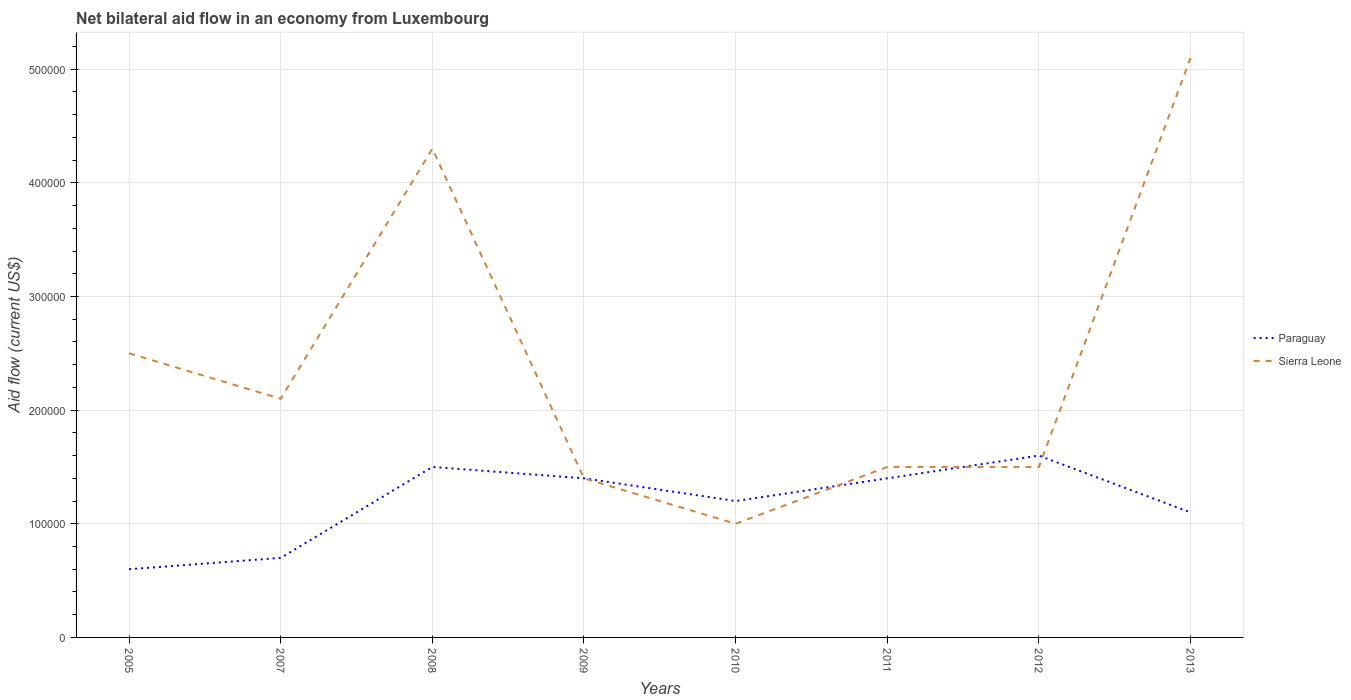How many different coloured lines are there?
Provide a short and direct response. 2. Does the line corresponding to Sierra Leone intersect with the line corresponding to Paraguay?
Keep it short and to the point. Yes. Across all years, what is the maximum net bilateral aid flow in Paraguay?
Provide a succinct answer. 6.00e+04. In which year was the net bilateral aid flow in Sierra Leone maximum?
Keep it short and to the point. 2010. What is the total net bilateral aid flow in Sierra Leone in the graph?
Your answer should be very brief. 1.10e+05. What is the difference between the highest and the second highest net bilateral aid flow in Paraguay?
Make the answer very short. 1.00e+05. Is the net bilateral aid flow in Paraguay strictly greater than the net bilateral aid flow in Sierra Leone over the years?
Offer a very short reply. No. How many lines are there?
Provide a short and direct response. 2. How many years are there in the graph?
Your answer should be compact. 8. Are the values on the major ticks of Y-axis written in scientific E-notation?
Provide a succinct answer. No. Does the graph contain grids?
Provide a succinct answer. Yes. What is the title of the graph?
Offer a very short reply. Net bilateral aid flow in an economy from Luxembourg. Does "Fiji" appear as one of the legend labels in the graph?
Ensure brevity in your answer.  No. What is the label or title of the X-axis?
Offer a terse response. Years. What is the label or title of the Y-axis?
Your answer should be very brief. Aid flow (current US$). What is the Aid flow (current US$) in Paraguay in 2005?
Make the answer very short. 6.00e+04. What is the Aid flow (current US$) of Sierra Leone in 2005?
Make the answer very short. 2.50e+05. What is the Aid flow (current US$) of Paraguay in 2007?
Provide a short and direct response. 7.00e+04. What is the Aid flow (current US$) of Sierra Leone in 2008?
Your answer should be compact. 4.30e+05. What is the Aid flow (current US$) in Paraguay in 2009?
Offer a very short reply. 1.40e+05. What is the Aid flow (current US$) of Paraguay in 2010?
Your answer should be very brief. 1.20e+05. What is the Aid flow (current US$) of Paraguay in 2011?
Your answer should be compact. 1.40e+05. What is the Aid flow (current US$) of Sierra Leone in 2011?
Make the answer very short. 1.50e+05. What is the Aid flow (current US$) in Paraguay in 2012?
Make the answer very short. 1.60e+05. What is the Aid flow (current US$) of Sierra Leone in 2012?
Your response must be concise. 1.50e+05. What is the Aid flow (current US$) of Paraguay in 2013?
Your response must be concise. 1.10e+05. What is the Aid flow (current US$) of Sierra Leone in 2013?
Give a very brief answer. 5.10e+05. Across all years, what is the maximum Aid flow (current US$) of Sierra Leone?
Provide a succinct answer. 5.10e+05. What is the total Aid flow (current US$) of Paraguay in the graph?
Provide a succinct answer. 9.50e+05. What is the total Aid flow (current US$) of Sierra Leone in the graph?
Make the answer very short. 1.94e+06. What is the difference between the Aid flow (current US$) in Sierra Leone in 2005 and that in 2007?
Offer a terse response. 4.00e+04. What is the difference between the Aid flow (current US$) of Paraguay in 2005 and that in 2008?
Offer a terse response. -9.00e+04. What is the difference between the Aid flow (current US$) in Paraguay in 2005 and that in 2009?
Your answer should be very brief. -8.00e+04. What is the difference between the Aid flow (current US$) of Paraguay in 2005 and that in 2010?
Offer a terse response. -6.00e+04. What is the difference between the Aid flow (current US$) of Paraguay in 2005 and that in 2011?
Your answer should be compact. -8.00e+04. What is the difference between the Aid flow (current US$) of Sierra Leone in 2005 and that in 2011?
Your answer should be very brief. 1.00e+05. What is the difference between the Aid flow (current US$) in Paraguay in 2005 and that in 2012?
Your response must be concise. -1.00e+05. What is the difference between the Aid flow (current US$) in Sierra Leone in 2005 and that in 2012?
Your answer should be very brief. 1.00e+05. What is the difference between the Aid flow (current US$) in Sierra Leone in 2005 and that in 2013?
Your response must be concise. -2.60e+05. What is the difference between the Aid flow (current US$) in Paraguay in 2007 and that in 2009?
Offer a very short reply. -7.00e+04. What is the difference between the Aid flow (current US$) of Paraguay in 2007 and that in 2010?
Ensure brevity in your answer.  -5.00e+04. What is the difference between the Aid flow (current US$) of Paraguay in 2007 and that in 2011?
Offer a terse response. -7.00e+04. What is the difference between the Aid flow (current US$) of Paraguay in 2007 and that in 2012?
Keep it short and to the point. -9.00e+04. What is the difference between the Aid flow (current US$) of Sierra Leone in 2007 and that in 2012?
Your response must be concise. 6.00e+04. What is the difference between the Aid flow (current US$) in Paraguay in 2007 and that in 2013?
Make the answer very short. -4.00e+04. What is the difference between the Aid flow (current US$) of Sierra Leone in 2007 and that in 2013?
Ensure brevity in your answer.  -3.00e+05. What is the difference between the Aid flow (current US$) of Paraguay in 2008 and that in 2009?
Your answer should be very brief. 10000. What is the difference between the Aid flow (current US$) in Paraguay in 2008 and that in 2010?
Make the answer very short. 3.00e+04. What is the difference between the Aid flow (current US$) in Sierra Leone in 2008 and that in 2010?
Keep it short and to the point. 3.30e+05. What is the difference between the Aid flow (current US$) of Sierra Leone in 2008 and that in 2011?
Ensure brevity in your answer.  2.80e+05. What is the difference between the Aid flow (current US$) in Paraguay in 2009 and that in 2010?
Provide a short and direct response. 2.00e+04. What is the difference between the Aid flow (current US$) of Sierra Leone in 2009 and that in 2013?
Give a very brief answer. -3.70e+05. What is the difference between the Aid flow (current US$) in Paraguay in 2010 and that in 2011?
Provide a succinct answer. -2.00e+04. What is the difference between the Aid flow (current US$) in Sierra Leone in 2010 and that in 2011?
Make the answer very short. -5.00e+04. What is the difference between the Aid flow (current US$) in Sierra Leone in 2010 and that in 2013?
Make the answer very short. -4.10e+05. What is the difference between the Aid flow (current US$) of Paraguay in 2011 and that in 2012?
Provide a short and direct response. -2.00e+04. What is the difference between the Aid flow (current US$) of Sierra Leone in 2011 and that in 2013?
Your answer should be very brief. -3.60e+05. What is the difference between the Aid flow (current US$) of Paraguay in 2012 and that in 2013?
Your response must be concise. 5.00e+04. What is the difference between the Aid flow (current US$) in Sierra Leone in 2012 and that in 2013?
Your answer should be compact. -3.60e+05. What is the difference between the Aid flow (current US$) of Paraguay in 2005 and the Aid flow (current US$) of Sierra Leone in 2008?
Provide a succinct answer. -3.70e+05. What is the difference between the Aid flow (current US$) in Paraguay in 2005 and the Aid flow (current US$) in Sierra Leone in 2009?
Make the answer very short. -8.00e+04. What is the difference between the Aid flow (current US$) of Paraguay in 2005 and the Aid flow (current US$) of Sierra Leone in 2010?
Make the answer very short. -4.00e+04. What is the difference between the Aid flow (current US$) of Paraguay in 2005 and the Aid flow (current US$) of Sierra Leone in 2012?
Your answer should be compact. -9.00e+04. What is the difference between the Aid flow (current US$) in Paraguay in 2005 and the Aid flow (current US$) in Sierra Leone in 2013?
Provide a short and direct response. -4.50e+05. What is the difference between the Aid flow (current US$) of Paraguay in 2007 and the Aid flow (current US$) of Sierra Leone in 2008?
Ensure brevity in your answer.  -3.60e+05. What is the difference between the Aid flow (current US$) of Paraguay in 2007 and the Aid flow (current US$) of Sierra Leone in 2011?
Your answer should be very brief. -8.00e+04. What is the difference between the Aid flow (current US$) in Paraguay in 2007 and the Aid flow (current US$) in Sierra Leone in 2012?
Give a very brief answer. -8.00e+04. What is the difference between the Aid flow (current US$) of Paraguay in 2007 and the Aid flow (current US$) of Sierra Leone in 2013?
Provide a short and direct response. -4.40e+05. What is the difference between the Aid flow (current US$) in Paraguay in 2008 and the Aid flow (current US$) in Sierra Leone in 2012?
Provide a short and direct response. 0. What is the difference between the Aid flow (current US$) in Paraguay in 2008 and the Aid flow (current US$) in Sierra Leone in 2013?
Keep it short and to the point. -3.60e+05. What is the difference between the Aid flow (current US$) of Paraguay in 2009 and the Aid flow (current US$) of Sierra Leone in 2012?
Offer a terse response. -10000. What is the difference between the Aid flow (current US$) in Paraguay in 2009 and the Aid flow (current US$) in Sierra Leone in 2013?
Provide a succinct answer. -3.70e+05. What is the difference between the Aid flow (current US$) in Paraguay in 2010 and the Aid flow (current US$) in Sierra Leone in 2013?
Your answer should be very brief. -3.90e+05. What is the difference between the Aid flow (current US$) of Paraguay in 2011 and the Aid flow (current US$) of Sierra Leone in 2013?
Offer a terse response. -3.70e+05. What is the difference between the Aid flow (current US$) in Paraguay in 2012 and the Aid flow (current US$) in Sierra Leone in 2013?
Give a very brief answer. -3.50e+05. What is the average Aid flow (current US$) of Paraguay per year?
Offer a very short reply. 1.19e+05. What is the average Aid flow (current US$) of Sierra Leone per year?
Your answer should be very brief. 2.42e+05. In the year 2005, what is the difference between the Aid flow (current US$) in Paraguay and Aid flow (current US$) in Sierra Leone?
Offer a terse response. -1.90e+05. In the year 2007, what is the difference between the Aid flow (current US$) of Paraguay and Aid flow (current US$) of Sierra Leone?
Ensure brevity in your answer.  -1.40e+05. In the year 2008, what is the difference between the Aid flow (current US$) of Paraguay and Aid flow (current US$) of Sierra Leone?
Offer a terse response. -2.80e+05. In the year 2009, what is the difference between the Aid flow (current US$) in Paraguay and Aid flow (current US$) in Sierra Leone?
Offer a terse response. 0. In the year 2011, what is the difference between the Aid flow (current US$) in Paraguay and Aid flow (current US$) in Sierra Leone?
Your answer should be very brief. -10000. In the year 2013, what is the difference between the Aid flow (current US$) in Paraguay and Aid flow (current US$) in Sierra Leone?
Provide a short and direct response. -4.00e+05. What is the ratio of the Aid flow (current US$) of Sierra Leone in 2005 to that in 2007?
Offer a terse response. 1.19. What is the ratio of the Aid flow (current US$) in Paraguay in 2005 to that in 2008?
Offer a very short reply. 0.4. What is the ratio of the Aid flow (current US$) in Sierra Leone in 2005 to that in 2008?
Make the answer very short. 0.58. What is the ratio of the Aid flow (current US$) of Paraguay in 2005 to that in 2009?
Your answer should be compact. 0.43. What is the ratio of the Aid flow (current US$) in Sierra Leone in 2005 to that in 2009?
Give a very brief answer. 1.79. What is the ratio of the Aid flow (current US$) of Paraguay in 2005 to that in 2011?
Your response must be concise. 0.43. What is the ratio of the Aid flow (current US$) in Sierra Leone in 2005 to that in 2011?
Offer a terse response. 1.67. What is the ratio of the Aid flow (current US$) in Sierra Leone in 2005 to that in 2012?
Make the answer very short. 1.67. What is the ratio of the Aid flow (current US$) in Paraguay in 2005 to that in 2013?
Your answer should be compact. 0.55. What is the ratio of the Aid flow (current US$) of Sierra Leone in 2005 to that in 2013?
Provide a succinct answer. 0.49. What is the ratio of the Aid flow (current US$) of Paraguay in 2007 to that in 2008?
Ensure brevity in your answer.  0.47. What is the ratio of the Aid flow (current US$) of Sierra Leone in 2007 to that in 2008?
Your response must be concise. 0.49. What is the ratio of the Aid flow (current US$) of Paraguay in 2007 to that in 2009?
Give a very brief answer. 0.5. What is the ratio of the Aid flow (current US$) in Paraguay in 2007 to that in 2010?
Give a very brief answer. 0.58. What is the ratio of the Aid flow (current US$) in Sierra Leone in 2007 to that in 2010?
Offer a very short reply. 2.1. What is the ratio of the Aid flow (current US$) of Paraguay in 2007 to that in 2011?
Provide a succinct answer. 0.5. What is the ratio of the Aid flow (current US$) of Paraguay in 2007 to that in 2012?
Give a very brief answer. 0.44. What is the ratio of the Aid flow (current US$) in Sierra Leone in 2007 to that in 2012?
Your answer should be compact. 1.4. What is the ratio of the Aid flow (current US$) of Paraguay in 2007 to that in 2013?
Your answer should be very brief. 0.64. What is the ratio of the Aid flow (current US$) in Sierra Leone in 2007 to that in 2013?
Offer a terse response. 0.41. What is the ratio of the Aid flow (current US$) in Paraguay in 2008 to that in 2009?
Make the answer very short. 1.07. What is the ratio of the Aid flow (current US$) in Sierra Leone in 2008 to that in 2009?
Your answer should be very brief. 3.07. What is the ratio of the Aid flow (current US$) of Paraguay in 2008 to that in 2010?
Offer a very short reply. 1.25. What is the ratio of the Aid flow (current US$) of Sierra Leone in 2008 to that in 2010?
Provide a short and direct response. 4.3. What is the ratio of the Aid flow (current US$) of Paraguay in 2008 to that in 2011?
Provide a short and direct response. 1.07. What is the ratio of the Aid flow (current US$) of Sierra Leone in 2008 to that in 2011?
Make the answer very short. 2.87. What is the ratio of the Aid flow (current US$) of Paraguay in 2008 to that in 2012?
Provide a succinct answer. 0.94. What is the ratio of the Aid flow (current US$) in Sierra Leone in 2008 to that in 2012?
Make the answer very short. 2.87. What is the ratio of the Aid flow (current US$) in Paraguay in 2008 to that in 2013?
Your answer should be very brief. 1.36. What is the ratio of the Aid flow (current US$) of Sierra Leone in 2008 to that in 2013?
Provide a short and direct response. 0.84. What is the ratio of the Aid flow (current US$) in Paraguay in 2009 to that in 2010?
Your answer should be compact. 1.17. What is the ratio of the Aid flow (current US$) of Sierra Leone in 2009 to that in 2010?
Give a very brief answer. 1.4. What is the ratio of the Aid flow (current US$) in Paraguay in 2009 to that in 2011?
Your answer should be compact. 1. What is the ratio of the Aid flow (current US$) of Sierra Leone in 2009 to that in 2012?
Offer a terse response. 0.93. What is the ratio of the Aid flow (current US$) in Paraguay in 2009 to that in 2013?
Your answer should be very brief. 1.27. What is the ratio of the Aid flow (current US$) of Sierra Leone in 2009 to that in 2013?
Keep it short and to the point. 0.27. What is the ratio of the Aid flow (current US$) of Paraguay in 2010 to that in 2011?
Keep it short and to the point. 0.86. What is the ratio of the Aid flow (current US$) in Paraguay in 2010 to that in 2013?
Your answer should be very brief. 1.09. What is the ratio of the Aid flow (current US$) of Sierra Leone in 2010 to that in 2013?
Your response must be concise. 0.2. What is the ratio of the Aid flow (current US$) in Paraguay in 2011 to that in 2013?
Your answer should be very brief. 1.27. What is the ratio of the Aid flow (current US$) in Sierra Leone in 2011 to that in 2013?
Make the answer very short. 0.29. What is the ratio of the Aid flow (current US$) of Paraguay in 2012 to that in 2013?
Provide a succinct answer. 1.45. What is the ratio of the Aid flow (current US$) in Sierra Leone in 2012 to that in 2013?
Give a very brief answer. 0.29. What is the difference between the highest and the second highest Aid flow (current US$) in Paraguay?
Your answer should be very brief. 10000. What is the difference between the highest and the lowest Aid flow (current US$) of Paraguay?
Make the answer very short. 1.00e+05. 